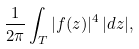<formula> <loc_0><loc_0><loc_500><loc_500>\frac { 1 } { 2 \pi } \int _ { T } | f ( z ) | ^ { 4 } \, | d z | ,</formula> 